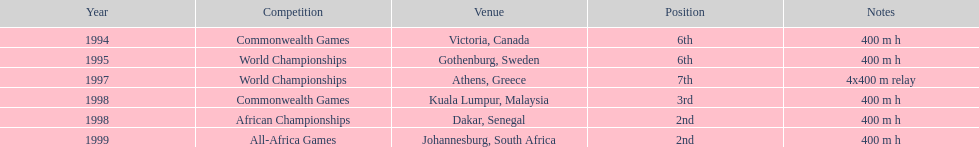Which year witnessed the highest number of competitions? 1998. 